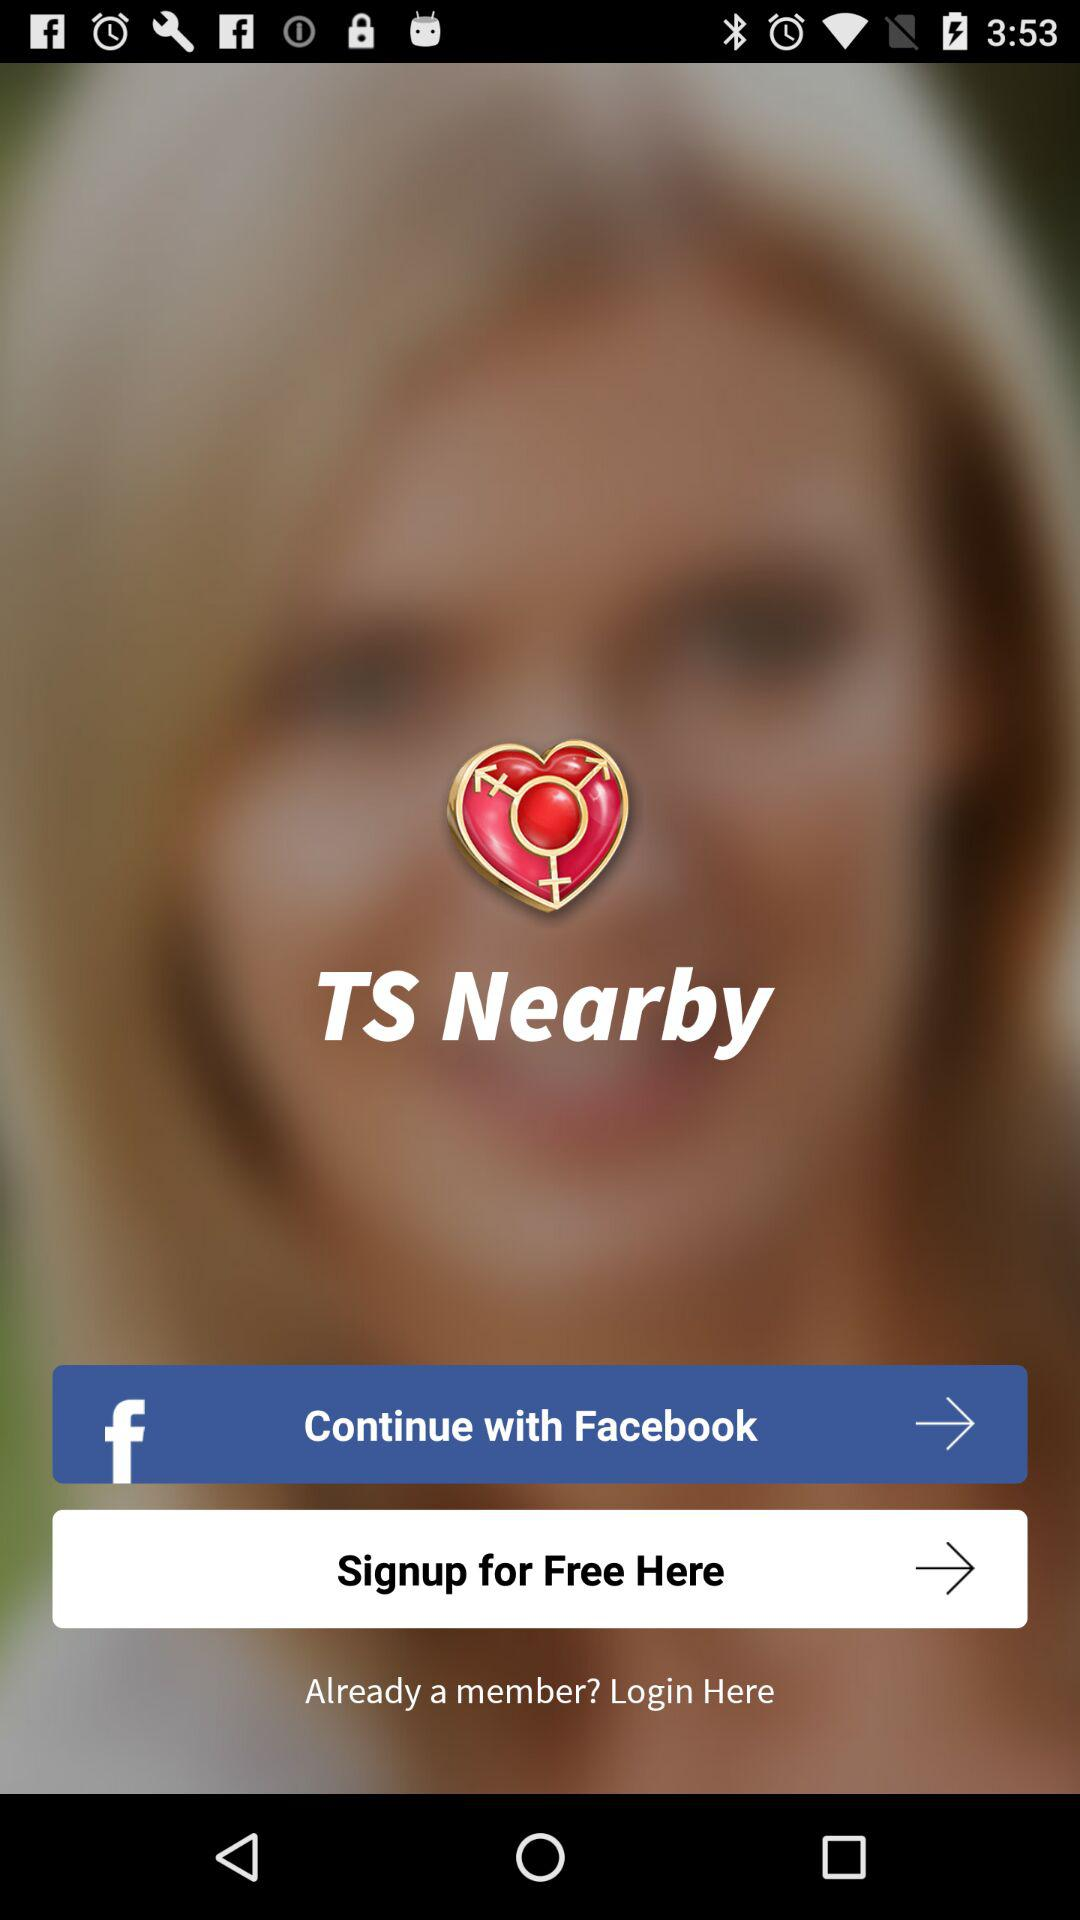What is the application name? The application name is "TS Nearby". 